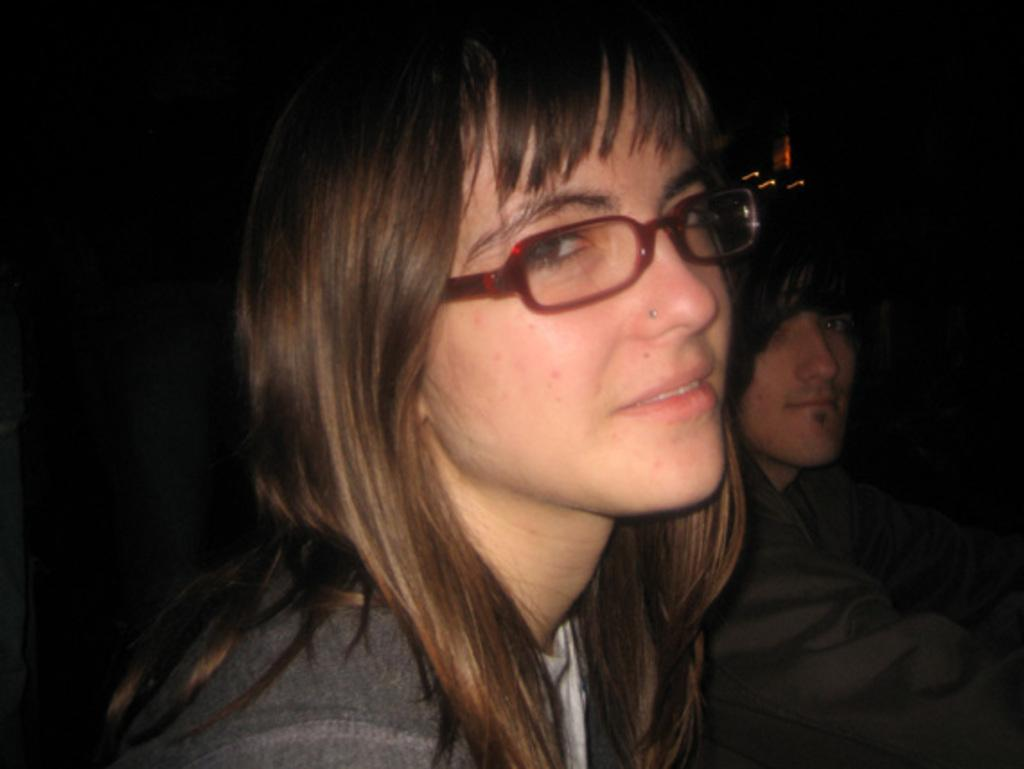How many people are in the image? There are two persons in the image. What can be observed about the background of the image? The background of the image is dark. How many girls are present in the image? The provided facts do not mention the gender of the persons in the image, so it cannot be determined if there are any girls present. 